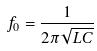<formula> <loc_0><loc_0><loc_500><loc_500>f _ { 0 } = \frac { 1 } { 2 \pi \sqrt { L C } }</formula> 